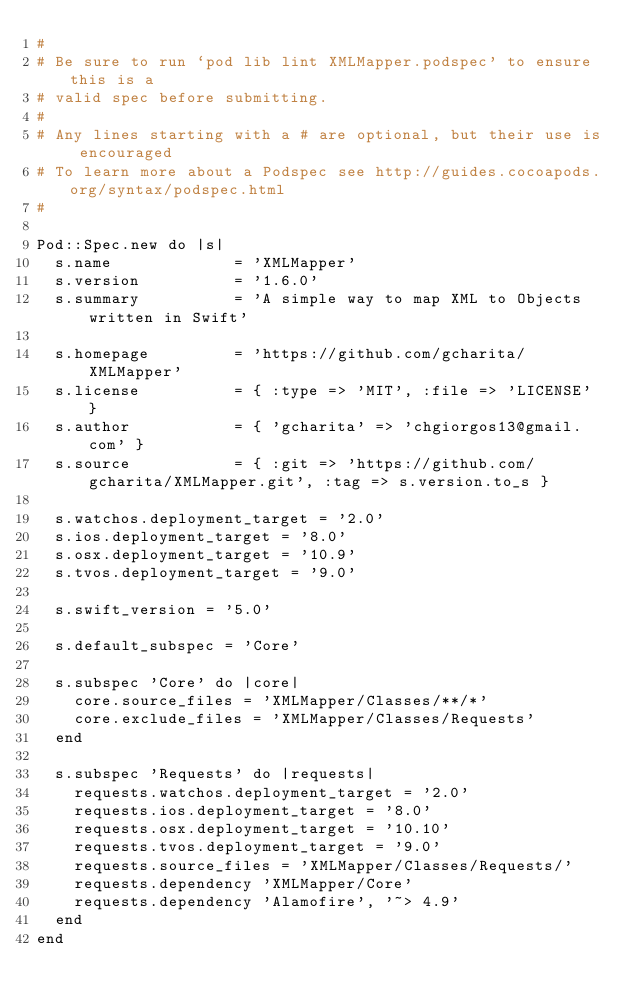<code> <loc_0><loc_0><loc_500><loc_500><_Ruby_>#
# Be sure to run `pod lib lint XMLMapper.podspec' to ensure this is a
# valid spec before submitting.
#
# Any lines starting with a # are optional, but their use is encouraged
# To learn more about a Podspec see http://guides.cocoapods.org/syntax/podspec.html
#

Pod::Spec.new do |s|
  s.name             = 'XMLMapper'
  s.version          = '1.6.0'
  s.summary          = 'A simple way to map XML to Objects written in Swift'

  s.homepage         = 'https://github.com/gcharita/XMLMapper'
  s.license          = { :type => 'MIT', :file => 'LICENSE' }
  s.author           = { 'gcharita' => 'chgiorgos13@gmail.com' }
  s.source           = { :git => 'https://github.com/gcharita/XMLMapper.git', :tag => s.version.to_s }

  s.watchos.deployment_target = '2.0'
  s.ios.deployment_target = '8.0'
  s.osx.deployment_target = '10.9'
  s.tvos.deployment_target = '9.0'

  s.swift_version = '5.0'

  s.default_subspec = 'Core'

  s.subspec 'Core' do |core|
    core.source_files = 'XMLMapper/Classes/**/*'
    core.exclude_files = 'XMLMapper/Classes/Requests'
  end

  s.subspec 'Requests' do |requests|
    requests.watchos.deployment_target = '2.0'
    requests.ios.deployment_target = '8.0'
    requests.osx.deployment_target = '10.10'
    requests.tvos.deployment_target = '9.0'
    requests.source_files = 'XMLMapper/Classes/Requests/'
    requests.dependency 'XMLMapper/Core'
    requests.dependency 'Alamofire', '~> 4.9'
  end
end
</code> 